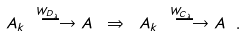<formula> <loc_0><loc_0><loc_500><loc_500>A _ { k } \overset { W _ { D _ { \lambda } } \ } { \ \longrightarrow } A \ \Rightarrow \ A _ { k } \overset { W _ { C _ { \lambda } } \ } { \ \longrightarrow } A \ .</formula> 